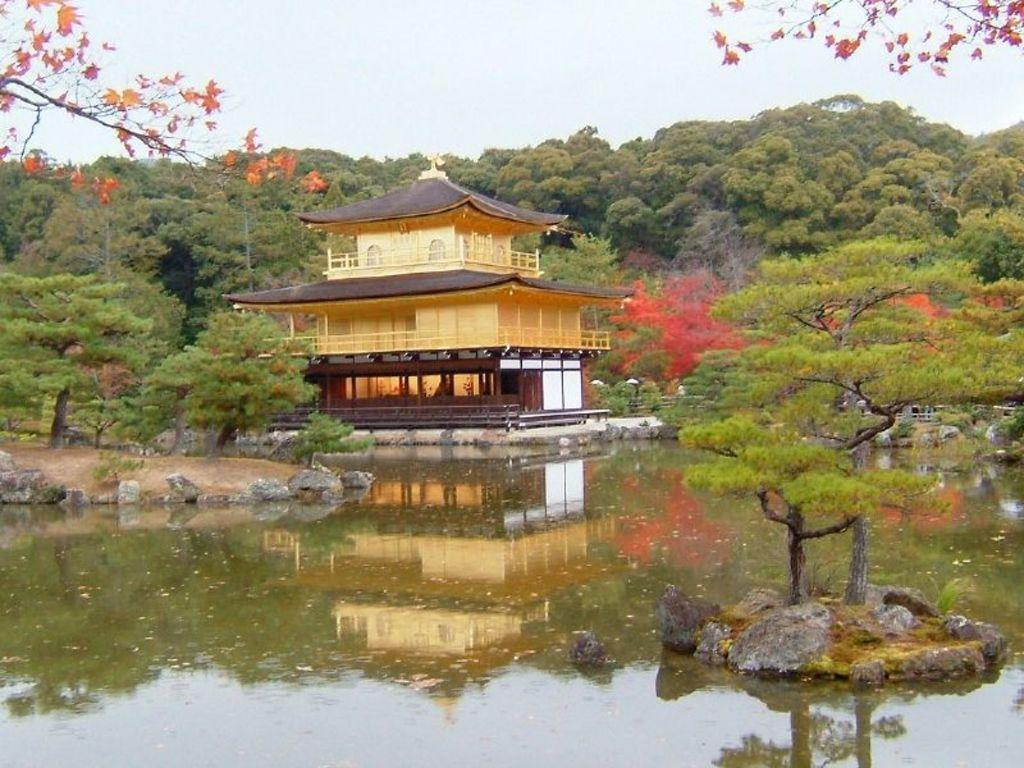What is the main element present in the image? There is water in the image. Can you describe the house in the image? The house in the image has a yellow and black color. What type of vegetation can be seen in the background of the image? There are green color trees in the background of the image. What is visible at the top of the image? The sky is visible at the top of the image. What type of cracker is floating on the water in the image? There is no cracker present in the image; it only features water, a yellow and black house, green trees, and the sky. Can you describe the cushion on the yellow and black house in the image? There is no cushion present on the yellow and black house in the image. 